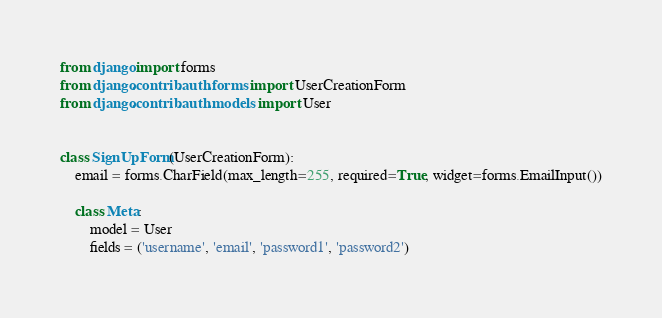Convert code to text. <code><loc_0><loc_0><loc_500><loc_500><_Python_>from django import forms
from django.contrib.auth.forms import UserCreationForm
from django.contrib.auth.models import User


class SignUpForm(UserCreationForm):
    email = forms.CharField(max_length=255, required=True, widget=forms.EmailInput())

    class Meta:
        model = User
        fields = ('username', 'email', 'password1', 'password2')
</code> 